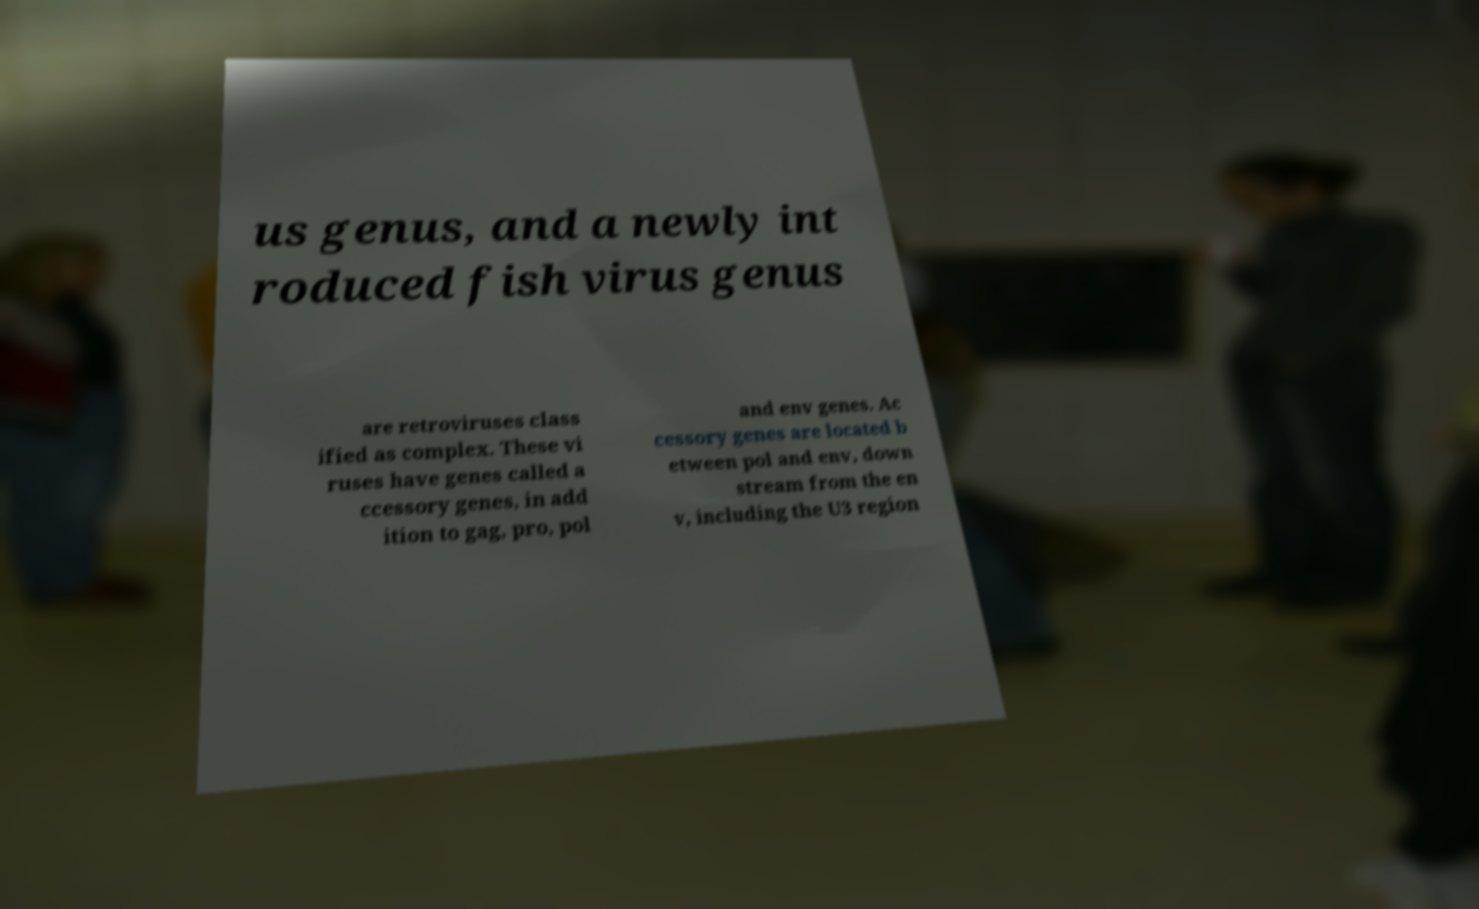Could you assist in decoding the text presented in this image and type it out clearly? us genus, and a newly int roduced fish virus genus are retroviruses class ified as complex. These vi ruses have genes called a ccessory genes, in add ition to gag, pro, pol and env genes. Ac cessory genes are located b etween pol and env, down stream from the en v, including the U3 region 